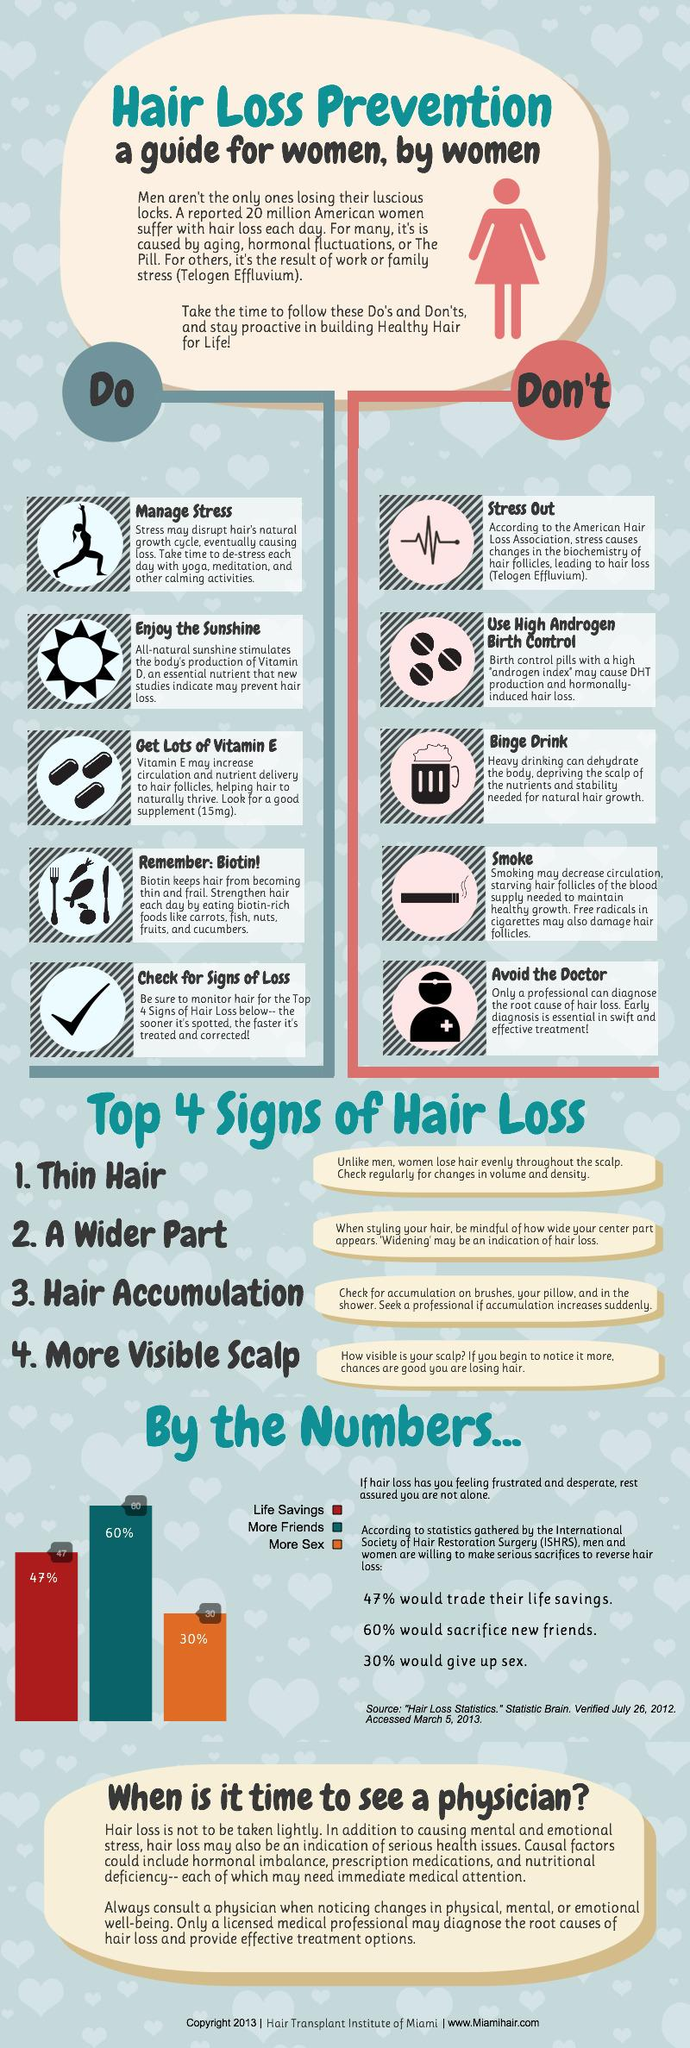Give some essential details in this illustration. Vitamin D and Vitamin E are essential for promoting healthy hair growth. 